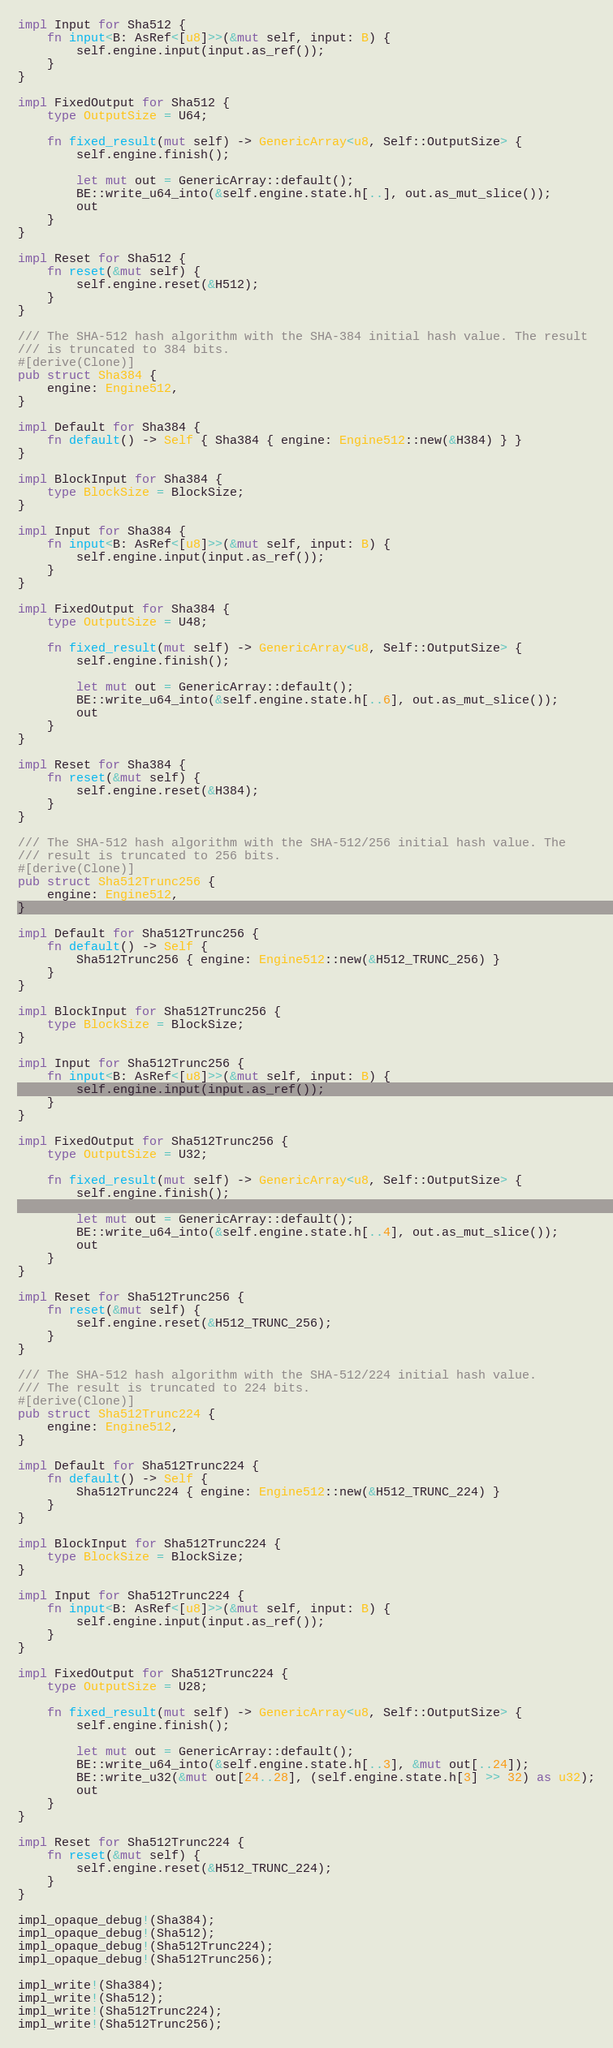<code> <loc_0><loc_0><loc_500><loc_500><_Rust_>
impl Input for Sha512 {
    fn input<B: AsRef<[u8]>>(&mut self, input: B) {
        self.engine.input(input.as_ref());
    }
}

impl FixedOutput for Sha512 {
    type OutputSize = U64;

    fn fixed_result(mut self) -> GenericArray<u8, Self::OutputSize> {
        self.engine.finish();

        let mut out = GenericArray::default();
        BE::write_u64_into(&self.engine.state.h[..], out.as_mut_slice());
        out
    }
}

impl Reset for Sha512 {
    fn reset(&mut self) {
        self.engine.reset(&H512);
    }
}

/// The SHA-512 hash algorithm with the SHA-384 initial hash value. The result
/// is truncated to 384 bits.
#[derive(Clone)]
pub struct Sha384 {
    engine: Engine512,
}

impl Default for Sha384 {
    fn default() -> Self { Sha384 { engine: Engine512::new(&H384) } }
}

impl BlockInput for Sha384 {
    type BlockSize = BlockSize;
}

impl Input for Sha384 {
    fn input<B: AsRef<[u8]>>(&mut self, input: B) {
        self.engine.input(input.as_ref());
    }
}

impl FixedOutput for Sha384 {
    type OutputSize = U48;

    fn fixed_result(mut self) -> GenericArray<u8, Self::OutputSize> {
        self.engine.finish();

        let mut out = GenericArray::default();
        BE::write_u64_into(&self.engine.state.h[..6], out.as_mut_slice());
        out
    }
}

impl Reset for Sha384 {
    fn reset(&mut self) {
        self.engine.reset(&H384);
    }
}

/// The SHA-512 hash algorithm with the SHA-512/256 initial hash value. The
/// result is truncated to 256 bits.
#[derive(Clone)]
pub struct Sha512Trunc256 {
    engine: Engine512,
}

impl Default for Sha512Trunc256 {
    fn default() -> Self {
        Sha512Trunc256 { engine: Engine512::new(&H512_TRUNC_256) }
    }
}

impl BlockInput for Sha512Trunc256 {
    type BlockSize = BlockSize;
}

impl Input for Sha512Trunc256 {
    fn input<B: AsRef<[u8]>>(&mut self, input: B) {
        self.engine.input(input.as_ref());
    }
}

impl FixedOutput for Sha512Trunc256 {
    type OutputSize = U32;

    fn fixed_result(mut self) -> GenericArray<u8, Self::OutputSize> {
        self.engine.finish();

        let mut out = GenericArray::default();
        BE::write_u64_into(&self.engine.state.h[..4], out.as_mut_slice());
        out
    }
}

impl Reset for Sha512Trunc256 {
    fn reset(&mut self) {
        self.engine.reset(&H512_TRUNC_256);
    }
}

/// The SHA-512 hash algorithm with the SHA-512/224 initial hash value.
/// The result is truncated to 224 bits.
#[derive(Clone)]
pub struct Sha512Trunc224 {
    engine: Engine512,
}

impl Default for Sha512Trunc224 {
    fn default() -> Self {
        Sha512Trunc224 { engine: Engine512::new(&H512_TRUNC_224) }
    }
}

impl BlockInput for Sha512Trunc224 {
    type BlockSize = BlockSize;
}

impl Input for Sha512Trunc224 {
    fn input<B: AsRef<[u8]>>(&mut self, input: B) {
        self.engine.input(input.as_ref());
    }
}

impl FixedOutput for Sha512Trunc224 {
    type OutputSize = U28;

    fn fixed_result(mut self) -> GenericArray<u8, Self::OutputSize> {
        self.engine.finish();

        let mut out = GenericArray::default();
        BE::write_u64_into(&self.engine.state.h[..3], &mut out[..24]);
        BE::write_u32(&mut out[24..28], (self.engine.state.h[3] >> 32) as u32);
        out
    }
}

impl Reset for Sha512Trunc224 {
    fn reset(&mut self) {
        self.engine.reset(&H512_TRUNC_224);
    }
}

impl_opaque_debug!(Sha384);
impl_opaque_debug!(Sha512);
impl_opaque_debug!(Sha512Trunc224);
impl_opaque_debug!(Sha512Trunc256);

impl_write!(Sha384);
impl_write!(Sha512);
impl_write!(Sha512Trunc224);
impl_write!(Sha512Trunc256);
</code> 